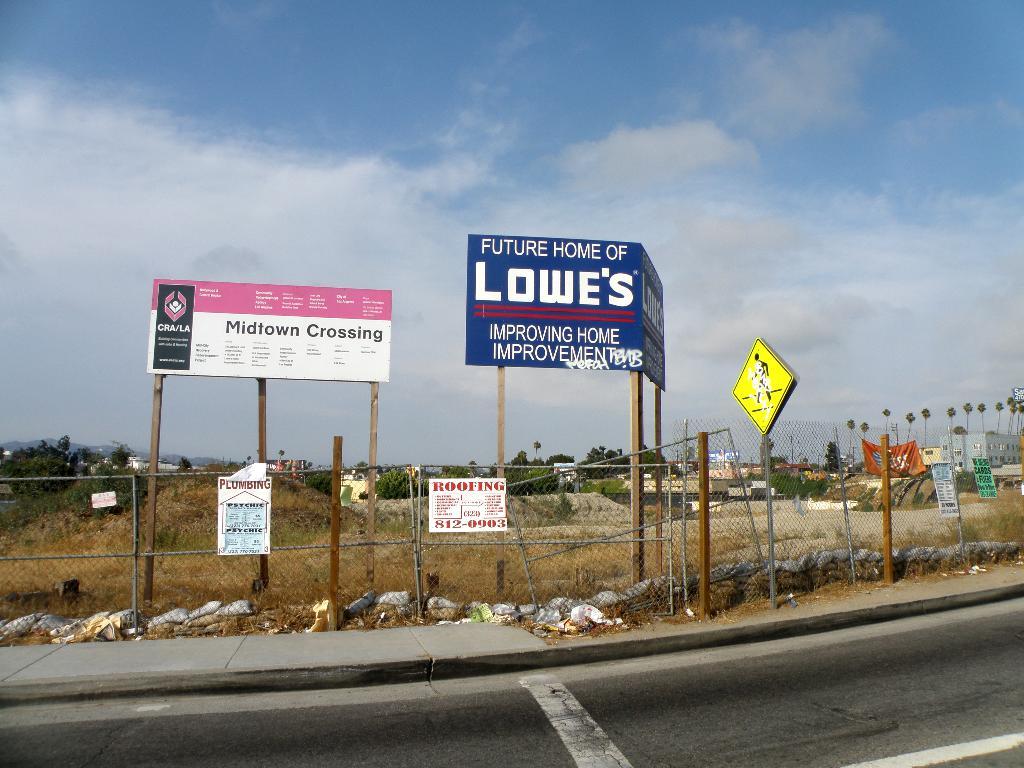What is this construction site the future home of?
Provide a succinct answer. Lowe's. What will be the name of the corssing?
Your answer should be compact. Midtown. 